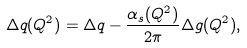Convert formula to latex. <formula><loc_0><loc_0><loc_500><loc_500>\Delta q ( Q ^ { 2 } ) = \Delta q - \frac { \alpha _ { s } ( Q ^ { 2 } ) } { 2 \pi } \Delta g ( Q ^ { 2 } ) ,</formula> 